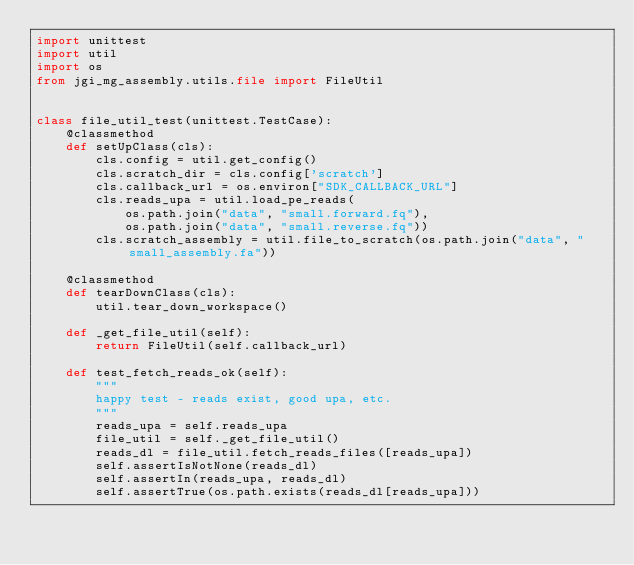<code> <loc_0><loc_0><loc_500><loc_500><_Python_>import unittest
import util
import os
from jgi_mg_assembly.utils.file import FileUtil


class file_util_test(unittest.TestCase):
    @classmethod
    def setUpClass(cls):
        cls.config = util.get_config()
        cls.scratch_dir = cls.config['scratch']
        cls.callback_url = os.environ["SDK_CALLBACK_URL"]
        cls.reads_upa = util.load_pe_reads(
            os.path.join("data", "small.forward.fq"),
            os.path.join("data", "small.reverse.fq"))
        cls.scratch_assembly = util.file_to_scratch(os.path.join("data", "small_assembly.fa"))

    @classmethod
    def tearDownClass(cls):
        util.tear_down_workspace()

    def _get_file_util(self):
        return FileUtil(self.callback_url)

    def test_fetch_reads_ok(self):
        """
        happy test - reads exist, good upa, etc.
        """
        reads_upa = self.reads_upa
        file_util = self._get_file_util()
        reads_dl = file_util.fetch_reads_files([reads_upa])
        self.assertIsNotNone(reads_dl)
        self.assertIn(reads_upa, reads_dl)
        self.assertTrue(os.path.exists(reads_dl[reads_upa]))
</code> 